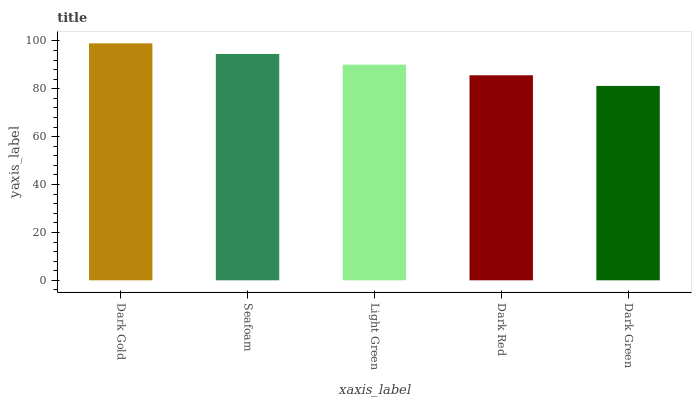Is Dark Green the minimum?
Answer yes or no. Yes. Is Dark Gold the maximum?
Answer yes or no. Yes. Is Seafoam the minimum?
Answer yes or no. No. Is Seafoam the maximum?
Answer yes or no. No. Is Dark Gold greater than Seafoam?
Answer yes or no. Yes. Is Seafoam less than Dark Gold?
Answer yes or no. Yes. Is Seafoam greater than Dark Gold?
Answer yes or no. No. Is Dark Gold less than Seafoam?
Answer yes or no. No. Is Light Green the high median?
Answer yes or no. Yes. Is Light Green the low median?
Answer yes or no. Yes. Is Dark Red the high median?
Answer yes or no. No. Is Seafoam the low median?
Answer yes or no. No. 